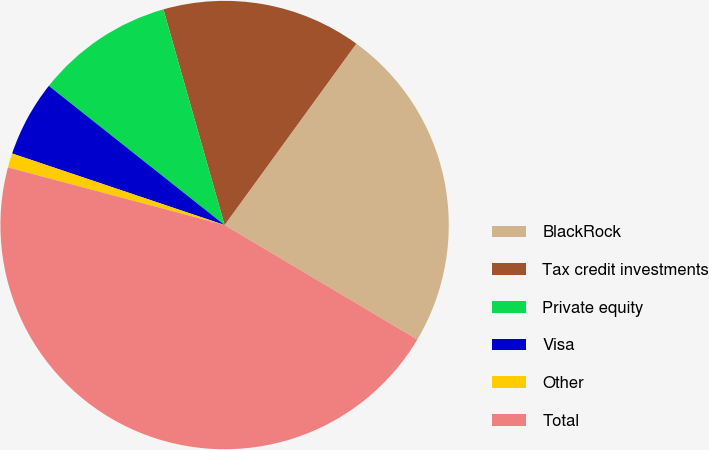Convert chart to OTSL. <chart><loc_0><loc_0><loc_500><loc_500><pie_chart><fcel>BlackRock<fcel>Tax credit investments<fcel>Private equity<fcel>Visa<fcel>Other<fcel>Total<nl><fcel>23.54%<fcel>14.4%<fcel>9.94%<fcel>5.49%<fcel>1.03%<fcel>45.61%<nl></chart> 